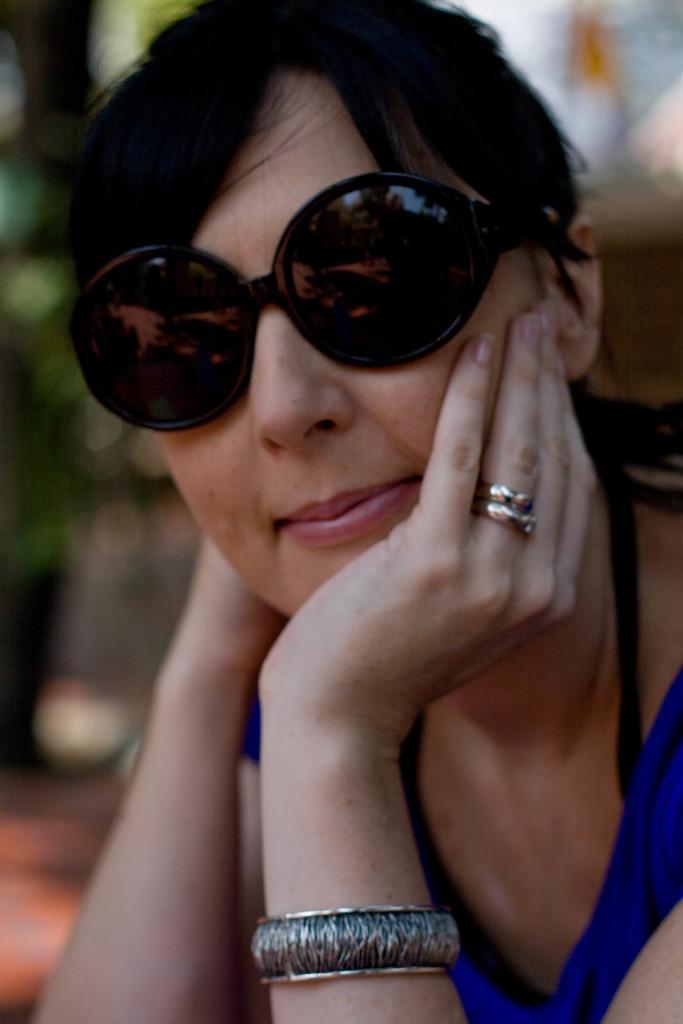Describe this image in one or two sentences. In the image in the center we can see one woman sitting and she is smiling,which we can see on her face. And we can see,she is wearing sunglasses. 